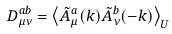Convert formula to latex. <formula><loc_0><loc_0><loc_500><loc_500>D ^ { a b } _ { \mu \nu } = \left \langle \tilde { A } ^ { a } _ { \mu } ( k ) \tilde { A } ^ { b } _ { \nu } ( - k ) \right \rangle _ { U }</formula> 